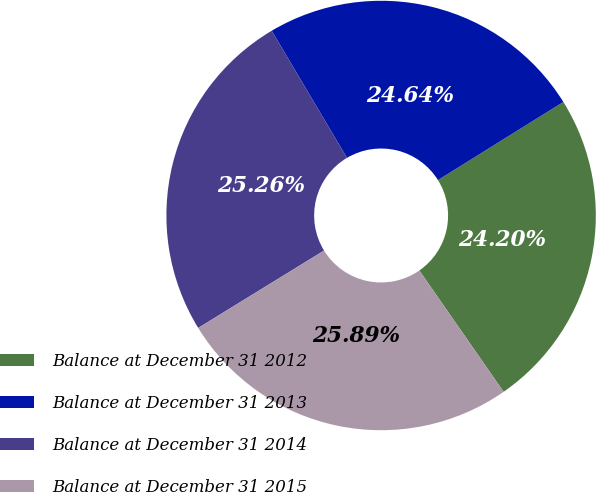Convert chart to OTSL. <chart><loc_0><loc_0><loc_500><loc_500><pie_chart><fcel>Balance at December 31 2012<fcel>Balance at December 31 2013<fcel>Balance at December 31 2014<fcel>Balance at December 31 2015<nl><fcel>24.2%<fcel>24.64%<fcel>25.26%<fcel>25.89%<nl></chart> 